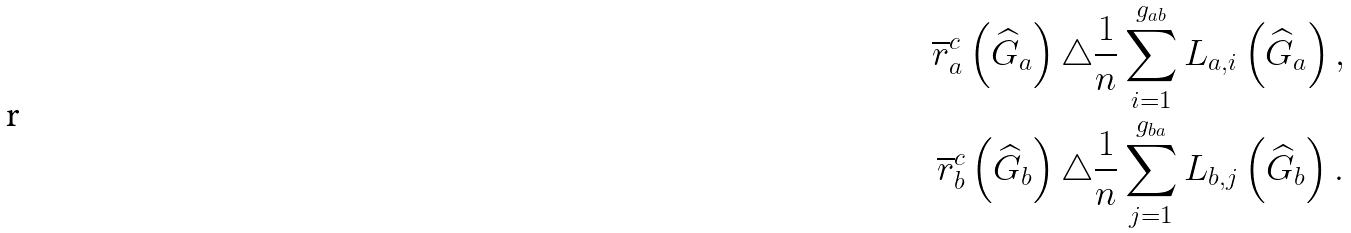Convert formula to latex. <formula><loc_0><loc_0><loc_500><loc_500>\overline { r } _ { a } ^ { c } \left ( \widehat { G } _ { a } \right ) \triangle & \frac { 1 } { n } \sum _ { i = 1 } ^ { g _ { a b } } L _ { a , i } \left ( \widehat { G } _ { a } \right ) , \\ \overline { r } _ { b } ^ { c } \left ( \widehat { G } _ { b } \right ) \triangle & \frac { 1 } { n } \sum _ { j = 1 } ^ { g _ { b a } } L _ { b , j } \left ( \widehat { G } _ { b } \right ) .</formula> 